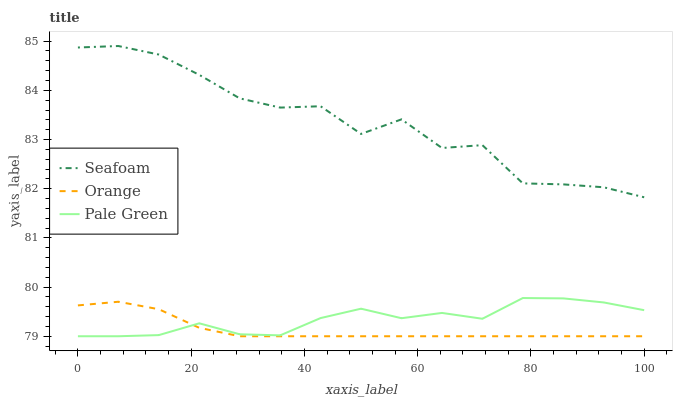Does Orange have the minimum area under the curve?
Answer yes or no. Yes. Does Seafoam have the maximum area under the curve?
Answer yes or no. Yes. Does Pale Green have the minimum area under the curve?
Answer yes or no. No. Does Pale Green have the maximum area under the curve?
Answer yes or no. No. Is Orange the smoothest?
Answer yes or no. Yes. Is Seafoam the roughest?
Answer yes or no. Yes. Is Pale Green the smoothest?
Answer yes or no. No. Is Pale Green the roughest?
Answer yes or no. No. Does Seafoam have the lowest value?
Answer yes or no. No. Does Seafoam have the highest value?
Answer yes or no. Yes. Does Pale Green have the highest value?
Answer yes or no. No. Is Orange less than Seafoam?
Answer yes or no. Yes. Is Seafoam greater than Orange?
Answer yes or no. Yes. Does Orange intersect Pale Green?
Answer yes or no. Yes. Is Orange less than Pale Green?
Answer yes or no. No. Is Orange greater than Pale Green?
Answer yes or no. No. Does Orange intersect Seafoam?
Answer yes or no. No. 